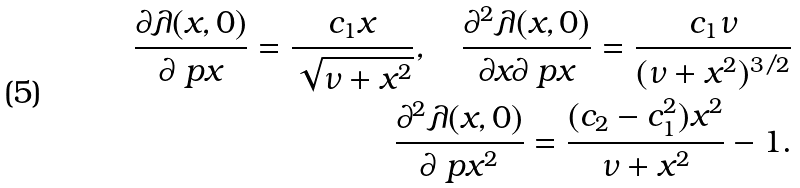Convert formula to latex. <formula><loc_0><loc_0><loc_500><loc_500>\frac { \partial \lambda ( x , 0 ) } { \partial \ p x } = \frac { c _ { 1 } x } { \sqrt { \nu + x ^ { 2 } } } , \quad \frac { \partial ^ { 2 } \lambda ( x , 0 ) } { \partial x \partial \ p x } = \frac { c _ { 1 } \nu } { ( \nu + x ^ { 2 } ) ^ { 3 / 2 } } \\ \frac { \partial ^ { 2 } \lambda ( x , 0 ) } { \partial \ p x ^ { 2 } } = \frac { ( c _ { 2 } - c _ { 1 } ^ { 2 } ) x ^ { 2 } } { \nu + x ^ { 2 } } - 1 .</formula> 